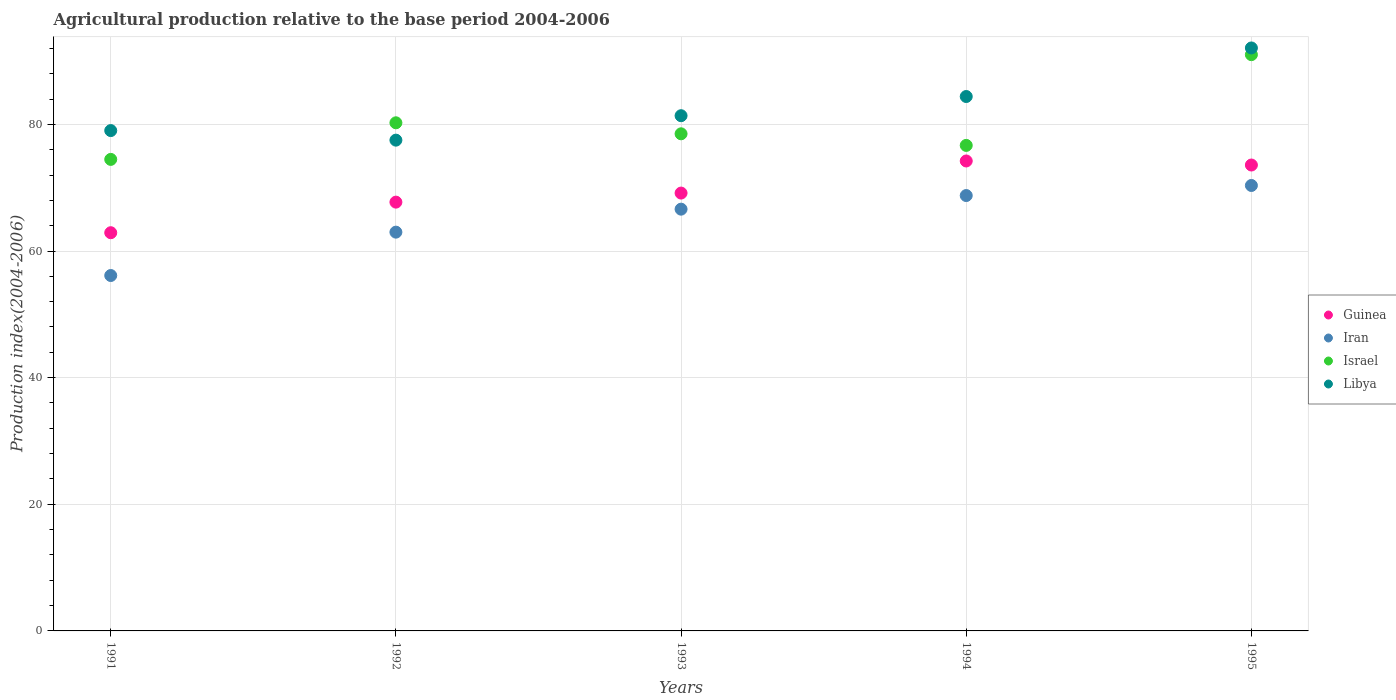Is the number of dotlines equal to the number of legend labels?
Offer a very short reply. Yes. What is the agricultural production index in Israel in 1993?
Offer a very short reply. 78.51. Across all years, what is the maximum agricultural production index in Israel?
Provide a succinct answer. 91.01. Across all years, what is the minimum agricultural production index in Libya?
Give a very brief answer. 77.51. What is the total agricultural production index in Guinea in the graph?
Ensure brevity in your answer.  347.56. What is the difference between the agricultural production index in Israel in 1992 and that in 1994?
Your answer should be compact. 3.57. What is the difference between the agricultural production index in Guinea in 1994 and the agricultural production index in Iran in 1995?
Provide a short and direct response. 3.87. What is the average agricultural production index in Israel per year?
Offer a terse response. 80.18. In the year 1991, what is the difference between the agricultural production index in Guinea and agricultural production index in Israel?
Offer a very short reply. -11.58. What is the ratio of the agricultural production index in Iran in 1992 to that in 1995?
Offer a very short reply. 0.9. Is the difference between the agricultural production index in Guinea in 1991 and 1992 greater than the difference between the agricultural production index in Israel in 1991 and 1992?
Make the answer very short. Yes. What is the difference between the highest and the second highest agricultural production index in Israel?
Offer a terse response. 10.76. What is the difference between the highest and the lowest agricultural production index in Guinea?
Offer a terse response. 11.33. Is the agricultural production index in Iran strictly less than the agricultural production index in Libya over the years?
Make the answer very short. Yes. What is the difference between two consecutive major ticks on the Y-axis?
Offer a very short reply. 20. How many legend labels are there?
Offer a very short reply. 4. How are the legend labels stacked?
Provide a short and direct response. Vertical. What is the title of the graph?
Your response must be concise. Agricultural production relative to the base period 2004-2006. Does "Small states" appear as one of the legend labels in the graph?
Provide a succinct answer. No. What is the label or title of the Y-axis?
Offer a terse response. Production index(2004-2006). What is the Production index(2004-2006) in Guinea in 1991?
Provide a short and direct response. 62.89. What is the Production index(2004-2006) of Iran in 1991?
Give a very brief answer. 56.13. What is the Production index(2004-2006) of Israel in 1991?
Ensure brevity in your answer.  74.47. What is the Production index(2004-2006) in Libya in 1991?
Provide a short and direct response. 79.02. What is the Production index(2004-2006) in Guinea in 1992?
Provide a succinct answer. 67.72. What is the Production index(2004-2006) in Iran in 1992?
Offer a very short reply. 62.98. What is the Production index(2004-2006) of Israel in 1992?
Your response must be concise. 80.25. What is the Production index(2004-2006) of Libya in 1992?
Give a very brief answer. 77.51. What is the Production index(2004-2006) in Guinea in 1993?
Make the answer very short. 69.15. What is the Production index(2004-2006) in Iran in 1993?
Ensure brevity in your answer.  66.61. What is the Production index(2004-2006) in Israel in 1993?
Your answer should be very brief. 78.51. What is the Production index(2004-2006) of Libya in 1993?
Ensure brevity in your answer.  81.37. What is the Production index(2004-2006) of Guinea in 1994?
Your answer should be very brief. 74.22. What is the Production index(2004-2006) of Iran in 1994?
Offer a very short reply. 68.76. What is the Production index(2004-2006) of Israel in 1994?
Offer a very short reply. 76.68. What is the Production index(2004-2006) of Libya in 1994?
Provide a short and direct response. 84.4. What is the Production index(2004-2006) in Guinea in 1995?
Offer a terse response. 73.58. What is the Production index(2004-2006) in Iran in 1995?
Make the answer very short. 70.35. What is the Production index(2004-2006) of Israel in 1995?
Your answer should be compact. 91.01. What is the Production index(2004-2006) in Libya in 1995?
Your answer should be compact. 92.07. Across all years, what is the maximum Production index(2004-2006) in Guinea?
Keep it short and to the point. 74.22. Across all years, what is the maximum Production index(2004-2006) in Iran?
Your answer should be compact. 70.35. Across all years, what is the maximum Production index(2004-2006) of Israel?
Provide a succinct answer. 91.01. Across all years, what is the maximum Production index(2004-2006) of Libya?
Your answer should be compact. 92.07. Across all years, what is the minimum Production index(2004-2006) of Guinea?
Offer a very short reply. 62.89. Across all years, what is the minimum Production index(2004-2006) of Iran?
Your answer should be compact. 56.13. Across all years, what is the minimum Production index(2004-2006) in Israel?
Offer a very short reply. 74.47. Across all years, what is the minimum Production index(2004-2006) of Libya?
Offer a terse response. 77.51. What is the total Production index(2004-2006) of Guinea in the graph?
Provide a succinct answer. 347.56. What is the total Production index(2004-2006) of Iran in the graph?
Your answer should be compact. 324.83. What is the total Production index(2004-2006) of Israel in the graph?
Ensure brevity in your answer.  400.92. What is the total Production index(2004-2006) in Libya in the graph?
Make the answer very short. 414.37. What is the difference between the Production index(2004-2006) of Guinea in 1991 and that in 1992?
Offer a terse response. -4.83. What is the difference between the Production index(2004-2006) of Iran in 1991 and that in 1992?
Make the answer very short. -6.85. What is the difference between the Production index(2004-2006) in Israel in 1991 and that in 1992?
Provide a short and direct response. -5.78. What is the difference between the Production index(2004-2006) of Libya in 1991 and that in 1992?
Keep it short and to the point. 1.51. What is the difference between the Production index(2004-2006) of Guinea in 1991 and that in 1993?
Offer a terse response. -6.26. What is the difference between the Production index(2004-2006) in Iran in 1991 and that in 1993?
Provide a short and direct response. -10.48. What is the difference between the Production index(2004-2006) in Israel in 1991 and that in 1993?
Your answer should be compact. -4.04. What is the difference between the Production index(2004-2006) in Libya in 1991 and that in 1993?
Provide a short and direct response. -2.35. What is the difference between the Production index(2004-2006) of Guinea in 1991 and that in 1994?
Offer a very short reply. -11.33. What is the difference between the Production index(2004-2006) of Iran in 1991 and that in 1994?
Keep it short and to the point. -12.63. What is the difference between the Production index(2004-2006) in Israel in 1991 and that in 1994?
Ensure brevity in your answer.  -2.21. What is the difference between the Production index(2004-2006) in Libya in 1991 and that in 1994?
Your response must be concise. -5.38. What is the difference between the Production index(2004-2006) in Guinea in 1991 and that in 1995?
Give a very brief answer. -10.69. What is the difference between the Production index(2004-2006) of Iran in 1991 and that in 1995?
Your response must be concise. -14.22. What is the difference between the Production index(2004-2006) of Israel in 1991 and that in 1995?
Offer a terse response. -16.54. What is the difference between the Production index(2004-2006) of Libya in 1991 and that in 1995?
Give a very brief answer. -13.05. What is the difference between the Production index(2004-2006) of Guinea in 1992 and that in 1993?
Ensure brevity in your answer.  -1.43. What is the difference between the Production index(2004-2006) of Iran in 1992 and that in 1993?
Offer a very short reply. -3.63. What is the difference between the Production index(2004-2006) of Israel in 1992 and that in 1993?
Offer a very short reply. 1.74. What is the difference between the Production index(2004-2006) in Libya in 1992 and that in 1993?
Keep it short and to the point. -3.86. What is the difference between the Production index(2004-2006) of Guinea in 1992 and that in 1994?
Offer a very short reply. -6.5. What is the difference between the Production index(2004-2006) of Iran in 1992 and that in 1994?
Keep it short and to the point. -5.78. What is the difference between the Production index(2004-2006) in Israel in 1992 and that in 1994?
Your answer should be very brief. 3.57. What is the difference between the Production index(2004-2006) of Libya in 1992 and that in 1994?
Provide a succinct answer. -6.89. What is the difference between the Production index(2004-2006) in Guinea in 1992 and that in 1995?
Your answer should be very brief. -5.86. What is the difference between the Production index(2004-2006) in Iran in 1992 and that in 1995?
Provide a short and direct response. -7.37. What is the difference between the Production index(2004-2006) in Israel in 1992 and that in 1995?
Provide a succinct answer. -10.76. What is the difference between the Production index(2004-2006) of Libya in 1992 and that in 1995?
Keep it short and to the point. -14.56. What is the difference between the Production index(2004-2006) in Guinea in 1993 and that in 1994?
Your answer should be very brief. -5.07. What is the difference between the Production index(2004-2006) in Iran in 1993 and that in 1994?
Provide a succinct answer. -2.15. What is the difference between the Production index(2004-2006) in Israel in 1993 and that in 1994?
Your answer should be compact. 1.83. What is the difference between the Production index(2004-2006) of Libya in 1993 and that in 1994?
Keep it short and to the point. -3.03. What is the difference between the Production index(2004-2006) of Guinea in 1993 and that in 1995?
Offer a terse response. -4.43. What is the difference between the Production index(2004-2006) of Iran in 1993 and that in 1995?
Keep it short and to the point. -3.74. What is the difference between the Production index(2004-2006) of Israel in 1993 and that in 1995?
Provide a succinct answer. -12.5. What is the difference between the Production index(2004-2006) in Libya in 1993 and that in 1995?
Your answer should be compact. -10.7. What is the difference between the Production index(2004-2006) of Guinea in 1994 and that in 1995?
Provide a succinct answer. 0.64. What is the difference between the Production index(2004-2006) in Iran in 1994 and that in 1995?
Make the answer very short. -1.59. What is the difference between the Production index(2004-2006) of Israel in 1994 and that in 1995?
Your answer should be very brief. -14.33. What is the difference between the Production index(2004-2006) of Libya in 1994 and that in 1995?
Your response must be concise. -7.67. What is the difference between the Production index(2004-2006) in Guinea in 1991 and the Production index(2004-2006) in Iran in 1992?
Keep it short and to the point. -0.09. What is the difference between the Production index(2004-2006) of Guinea in 1991 and the Production index(2004-2006) of Israel in 1992?
Give a very brief answer. -17.36. What is the difference between the Production index(2004-2006) of Guinea in 1991 and the Production index(2004-2006) of Libya in 1992?
Provide a short and direct response. -14.62. What is the difference between the Production index(2004-2006) in Iran in 1991 and the Production index(2004-2006) in Israel in 1992?
Provide a short and direct response. -24.12. What is the difference between the Production index(2004-2006) of Iran in 1991 and the Production index(2004-2006) of Libya in 1992?
Your answer should be very brief. -21.38. What is the difference between the Production index(2004-2006) in Israel in 1991 and the Production index(2004-2006) in Libya in 1992?
Offer a very short reply. -3.04. What is the difference between the Production index(2004-2006) of Guinea in 1991 and the Production index(2004-2006) of Iran in 1993?
Your answer should be compact. -3.72. What is the difference between the Production index(2004-2006) in Guinea in 1991 and the Production index(2004-2006) in Israel in 1993?
Provide a short and direct response. -15.62. What is the difference between the Production index(2004-2006) of Guinea in 1991 and the Production index(2004-2006) of Libya in 1993?
Offer a terse response. -18.48. What is the difference between the Production index(2004-2006) of Iran in 1991 and the Production index(2004-2006) of Israel in 1993?
Offer a terse response. -22.38. What is the difference between the Production index(2004-2006) in Iran in 1991 and the Production index(2004-2006) in Libya in 1993?
Give a very brief answer. -25.24. What is the difference between the Production index(2004-2006) in Guinea in 1991 and the Production index(2004-2006) in Iran in 1994?
Give a very brief answer. -5.87. What is the difference between the Production index(2004-2006) of Guinea in 1991 and the Production index(2004-2006) of Israel in 1994?
Offer a very short reply. -13.79. What is the difference between the Production index(2004-2006) in Guinea in 1991 and the Production index(2004-2006) in Libya in 1994?
Your response must be concise. -21.51. What is the difference between the Production index(2004-2006) of Iran in 1991 and the Production index(2004-2006) of Israel in 1994?
Ensure brevity in your answer.  -20.55. What is the difference between the Production index(2004-2006) in Iran in 1991 and the Production index(2004-2006) in Libya in 1994?
Make the answer very short. -28.27. What is the difference between the Production index(2004-2006) in Israel in 1991 and the Production index(2004-2006) in Libya in 1994?
Your response must be concise. -9.93. What is the difference between the Production index(2004-2006) in Guinea in 1991 and the Production index(2004-2006) in Iran in 1995?
Keep it short and to the point. -7.46. What is the difference between the Production index(2004-2006) in Guinea in 1991 and the Production index(2004-2006) in Israel in 1995?
Keep it short and to the point. -28.12. What is the difference between the Production index(2004-2006) in Guinea in 1991 and the Production index(2004-2006) in Libya in 1995?
Your answer should be very brief. -29.18. What is the difference between the Production index(2004-2006) in Iran in 1991 and the Production index(2004-2006) in Israel in 1995?
Offer a terse response. -34.88. What is the difference between the Production index(2004-2006) of Iran in 1991 and the Production index(2004-2006) of Libya in 1995?
Make the answer very short. -35.94. What is the difference between the Production index(2004-2006) in Israel in 1991 and the Production index(2004-2006) in Libya in 1995?
Your answer should be compact. -17.6. What is the difference between the Production index(2004-2006) in Guinea in 1992 and the Production index(2004-2006) in Iran in 1993?
Offer a very short reply. 1.11. What is the difference between the Production index(2004-2006) of Guinea in 1992 and the Production index(2004-2006) of Israel in 1993?
Keep it short and to the point. -10.79. What is the difference between the Production index(2004-2006) in Guinea in 1992 and the Production index(2004-2006) in Libya in 1993?
Keep it short and to the point. -13.65. What is the difference between the Production index(2004-2006) in Iran in 1992 and the Production index(2004-2006) in Israel in 1993?
Provide a succinct answer. -15.53. What is the difference between the Production index(2004-2006) of Iran in 1992 and the Production index(2004-2006) of Libya in 1993?
Give a very brief answer. -18.39. What is the difference between the Production index(2004-2006) of Israel in 1992 and the Production index(2004-2006) of Libya in 1993?
Your answer should be very brief. -1.12. What is the difference between the Production index(2004-2006) of Guinea in 1992 and the Production index(2004-2006) of Iran in 1994?
Offer a terse response. -1.04. What is the difference between the Production index(2004-2006) in Guinea in 1992 and the Production index(2004-2006) in Israel in 1994?
Your answer should be very brief. -8.96. What is the difference between the Production index(2004-2006) of Guinea in 1992 and the Production index(2004-2006) of Libya in 1994?
Offer a terse response. -16.68. What is the difference between the Production index(2004-2006) in Iran in 1992 and the Production index(2004-2006) in Israel in 1994?
Keep it short and to the point. -13.7. What is the difference between the Production index(2004-2006) in Iran in 1992 and the Production index(2004-2006) in Libya in 1994?
Keep it short and to the point. -21.42. What is the difference between the Production index(2004-2006) of Israel in 1992 and the Production index(2004-2006) of Libya in 1994?
Your answer should be compact. -4.15. What is the difference between the Production index(2004-2006) of Guinea in 1992 and the Production index(2004-2006) of Iran in 1995?
Provide a short and direct response. -2.63. What is the difference between the Production index(2004-2006) of Guinea in 1992 and the Production index(2004-2006) of Israel in 1995?
Provide a succinct answer. -23.29. What is the difference between the Production index(2004-2006) of Guinea in 1992 and the Production index(2004-2006) of Libya in 1995?
Ensure brevity in your answer.  -24.35. What is the difference between the Production index(2004-2006) of Iran in 1992 and the Production index(2004-2006) of Israel in 1995?
Provide a succinct answer. -28.03. What is the difference between the Production index(2004-2006) in Iran in 1992 and the Production index(2004-2006) in Libya in 1995?
Your response must be concise. -29.09. What is the difference between the Production index(2004-2006) in Israel in 1992 and the Production index(2004-2006) in Libya in 1995?
Provide a succinct answer. -11.82. What is the difference between the Production index(2004-2006) in Guinea in 1993 and the Production index(2004-2006) in Iran in 1994?
Provide a short and direct response. 0.39. What is the difference between the Production index(2004-2006) in Guinea in 1993 and the Production index(2004-2006) in Israel in 1994?
Offer a very short reply. -7.53. What is the difference between the Production index(2004-2006) of Guinea in 1993 and the Production index(2004-2006) of Libya in 1994?
Your answer should be very brief. -15.25. What is the difference between the Production index(2004-2006) in Iran in 1993 and the Production index(2004-2006) in Israel in 1994?
Your answer should be very brief. -10.07. What is the difference between the Production index(2004-2006) of Iran in 1993 and the Production index(2004-2006) of Libya in 1994?
Provide a succinct answer. -17.79. What is the difference between the Production index(2004-2006) in Israel in 1993 and the Production index(2004-2006) in Libya in 1994?
Your answer should be compact. -5.89. What is the difference between the Production index(2004-2006) of Guinea in 1993 and the Production index(2004-2006) of Israel in 1995?
Keep it short and to the point. -21.86. What is the difference between the Production index(2004-2006) of Guinea in 1993 and the Production index(2004-2006) of Libya in 1995?
Make the answer very short. -22.92. What is the difference between the Production index(2004-2006) in Iran in 1993 and the Production index(2004-2006) in Israel in 1995?
Your answer should be very brief. -24.4. What is the difference between the Production index(2004-2006) in Iran in 1993 and the Production index(2004-2006) in Libya in 1995?
Provide a succinct answer. -25.46. What is the difference between the Production index(2004-2006) of Israel in 1993 and the Production index(2004-2006) of Libya in 1995?
Your answer should be compact. -13.56. What is the difference between the Production index(2004-2006) in Guinea in 1994 and the Production index(2004-2006) in Iran in 1995?
Your answer should be compact. 3.87. What is the difference between the Production index(2004-2006) of Guinea in 1994 and the Production index(2004-2006) of Israel in 1995?
Ensure brevity in your answer.  -16.79. What is the difference between the Production index(2004-2006) of Guinea in 1994 and the Production index(2004-2006) of Libya in 1995?
Ensure brevity in your answer.  -17.85. What is the difference between the Production index(2004-2006) in Iran in 1994 and the Production index(2004-2006) in Israel in 1995?
Provide a succinct answer. -22.25. What is the difference between the Production index(2004-2006) in Iran in 1994 and the Production index(2004-2006) in Libya in 1995?
Make the answer very short. -23.31. What is the difference between the Production index(2004-2006) of Israel in 1994 and the Production index(2004-2006) of Libya in 1995?
Offer a very short reply. -15.39. What is the average Production index(2004-2006) of Guinea per year?
Ensure brevity in your answer.  69.51. What is the average Production index(2004-2006) of Iran per year?
Offer a very short reply. 64.97. What is the average Production index(2004-2006) in Israel per year?
Give a very brief answer. 80.18. What is the average Production index(2004-2006) in Libya per year?
Make the answer very short. 82.87. In the year 1991, what is the difference between the Production index(2004-2006) in Guinea and Production index(2004-2006) in Iran?
Your answer should be compact. 6.76. In the year 1991, what is the difference between the Production index(2004-2006) of Guinea and Production index(2004-2006) of Israel?
Your answer should be compact. -11.58. In the year 1991, what is the difference between the Production index(2004-2006) of Guinea and Production index(2004-2006) of Libya?
Keep it short and to the point. -16.13. In the year 1991, what is the difference between the Production index(2004-2006) in Iran and Production index(2004-2006) in Israel?
Keep it short and to the point. -18.34. In the year 1991, what is the difference between the Production index(2004-2006) of Iran and Production index(2004-2006) of Libya?
Provide a succinct answer. -22.89. In the year 1991, what is the difference between the Production index(2004-2006) of Israel and Production index(2004-2006) of Libya?
Your answer should be very brief. -4.55. In the year 1992, what is the difference between the Production index(2004-2006) in Guinea and Production index(2004-2006) in Iran?
Offer a terse response. 4.74. In the year 1992, what is the difference between the Production index(2004-2006) of Guinea and Production index(2004-2006) of Israel?
Your answer should be very brief. -12.53. In the year 1992, what is the difference between the Production index(2004-2006) of Guinea and Production index(2004-2006) of Libya?
Ensure brevity in your answer.  -9.79. In the year 1992, what is the difference between the Production index(2004-2006) in Iran and Production index(2004-2006) in Israel?
Give a very brief answer. -17.27. In the year 1992, what is the difference between the Production index(2004-2006) in Iran and Production index(2004-2006) in Libya?
Provide a short and direct response. -14.53. In the year 1992, what is the difference between the Production index(2004-2006) in Israel and Production index(2004-2006) in Libya?
Ensure brevity in your answer.  2.74. In the year 1993, what is the difference between the Production index(2004-2006) in Guinea and Production index(2004-2006) in Iran?
Ensure brevity in your answer.  2.54. In the year 1993, what is the difference between the Production index(2004-2006) in Guinea and Production index(2004-2006) in Israel?
Provide a succinct answer. -9.36. In the year 1993, what is the difference between the Production index(2004-2006) of Guinea and Production index(2004-2006) of Libya?
Offer a very short reply. -12.22. In the year 1993, what is the difference between the Production index(2004-2006) in Iran and Production index(2004-2006) in Libya?
Your answer should be very brief. -14.76. In the year 1993, what is the difference between the Production index(2004-2006) of Israel and Production index(2004-2006) of Libya?
Offer a terse response. -2.86. In the year 1994, what is the difference between the Production index(2004-2006) of Guinea and Production index(2004-2006) of Iran?
Ensure brevity in your answer.  5.46. In the year 1994, what is the difference between the Production index(2004-2006) in Guinea and Production index(2004-2006) in Israel?
Provide a succinct answer. -2.46. In the year 1994, what is the difference between the Production index(2004-2006) in Guinea and Production index(2004-2006) in Libya?
Provide a short and direct response. -10.18. In the year 1994, what is the difference between the Production index(2004-2006) in Iran and Production index(2004-2006) in Israel?
Give a very brief answer. -7.92. In the year 1994, what is the difference between the Production index(2004-2006) of Iran and Production index(2004-2006) of Libya?
Keep it short and to the point. -15.64. In the year 1994, what is the difference between the Production index(2004-2006) of Israel and Production index(2004-2006) of Libya?
Ensure brevity in your answer.  -7.72. In the year 1995, what is the difference between the Production index(2004-2006) of Guinea and Production index(2004-2006) of Iran?
Provide a short and direct response. 3.23. In the year 1995, what is the difference between the Production index(2004-2006) in Guinea and Production index(2004-2006) in Israel?
Offer a terse response. -17.43. In the year 1995, what is the difference between the Production index(2004-2006) in Guinea and Production index(2004-2006) in Libya?
Provide a short and direct response. -18.49. In the year 1995, what is the difference between the Production index(2004-2006) in Iran and Production index(2004-2006) in Israel?
Offer a very short reply. -20.66. In the year 1995, what is the difference between the Production index(2004-2006) of Iran and Production index(2004-2006) of Libya?
Provide a short and direct response. -21.72. In the year 1995, what is the difference between the Production index(2004-2006) in Israel and Production index(2004-2006) in Libya?
Offer a terse response. -1.06. What is the ratio of the Production index(2004-2006) in Guinea in 1991 to that in 1992?
Make the answer very short. 0.93. What is the ratio of the Production index(2004-2006) in Iran in 1991 to that in 1992?
Give a very brief answer. 0.89. What is the ratio of the Production index(2004-2006) of Israel in 1991 to that in 1992?
Ensure brevity in your answer.  0.93. What is the ratio of the Production index(2004-2006) in Libya in 1991 to that in 1992?
Ensure brevity in your answer.  1.02. What is the ratio of the Production index(2004-2006) in Guinea in 1991 to that in 1993?
Your response must be concise. 0.91. What is the ratio of the Production index(2004-2006) in Iran in 1991 to that in 1993?
Keep it short and to the point. 0.84. What is the ratio of the Production index(2004-2006) of Israel in 1991 to that in 1993?
Your answer should be compact. 0.95. What is the ratio of the Production index(2004-2006) in Libya in 1991 to that in 1993?
Your answer should be very brief. 0.97. What is the ratio of the Production index(2004-2006) in Guinea in 1991 to that in 1994?
Keep it short and to the point. 0.85. What is the ratio of the Production index(2004-2006) in Iran in 1991 to that in 1994?
Provide a succinct answer. 0.82. What is the ratio of the Production index(2004-2006) of Israel in 1991 to that in 1994?
Provide a short and direct response. 0.97. What is the ratio of the Production index(2004-2006) in Libya in 1991 to that in 1994?
Offer a terse response. 0.94. What is the ratio of the Production index(2004-2006) in Guinea in 1991 to that in 1995?
Offer a terse response. 0.85. What is the ratio of the Production index(2004-2006) of Iran in 1991 to that in 1995?
Your answer should be compact. 0.8. What is the ratio of the Production index(2004-2006) of Israel in 1991 to that in 1995?
Your answer should be compact. 0.82. What is the ratio of the Production index(2004-2006) of Libya in 1991 to that in 1995?
Provide a succinct answer. 0.86. What is the ratio of the Production index(2004-2006) in Guinea in 1992 to that in 1993?
Your answer should be very brief. 0.98. What is the ratio of the Production index(2004-2006) in Iran in 1992 to that in 1993?
Provide a succinct answer. 0.95. What is the ratio of the Production index(2004-2006) in Israel in 1992 to that in 1993?
Your answer should be compact. 1.02. What is the ratio of the Production index(2004-2006) in Libya in 1992 to that in 1993?
Offer a very short reply. 0.95. What is the ratio of the Production index(2004-2006) in Guinea in 1992 to that in 1994?
Make the answer very short. 0.91. What is the ratio of the Production index(2004-2006) in Iran in 1992 to that in 1994?
Provide a succinct answer. 0.92. What is the ratio of the Production index(2004-2006) of Israel in 1992 to that in 1994?
Your answer should be very brief. 1.05. What is the ratio of the Production index(2004-2006) of Libya in 1992 to that in 1994?
Ensure brevity in your answer.  0.92. What is the ratio of the Production index(2004-2006) of Guinea in 1992 to that in 1995?
Offer a terse response. 0.92. What is the ratio of the Production index(2004-2006) of Iran in 1992 to that in 1995?
Make the answer very short. 0.9. What is the ratio of the Production index(2004-2006) of Israel in 1992 to that in 1995?
Your response must be concise. 0.88. What is the ratio of the Production index(2004-2006) in Libya in 1992 to that in 1995?
Your answer should be compact. 0.84. What is the ratio of the Production index(2004-2006) in Guinea in 1993 to that in 1994?
Your answer should be compact. 0.93. What is the ratio of the Production index(2004-2006) of Iran in 1993 to that in 1994?
Make the answer very short. 0.97. What is the ratio of the Production index(2004-2006) of Israel in 1993 to that in 1994?
Ensure brevity in your answer.  1.02. What is the ratio of the Production index(2004-2006) in Libya in 1993 to that in 1994?
Keep it short and to the point. 0.96. What is the ratio of the Production index(2004-2006) of Guinea in 1993 to that in 1995?
Offer a terse response. 0.94. What is the ratio of the Production index(2004-2006) of Iran in 1993 to that in 1995?
Your answer should be very brief. 0.95. What is the ratio of the Production index(2004-2006) of Israel in 1993 to that in 1995?
Your response must be concise. 0.86. What is the ratio of the Production index(2004-2006) in Libya in 1993 to that in 1995?
Make the answer very short. 0.88. What is the ratio of the Production index(2004-2006) of Guinea in 1994 to that in 1995?
Make the answer very short. 1.01. What is the ratio of the Production index(2004-2006) in Iran in 1994 to that in 1995?
Give a very brief answer. 0.98. What is the ratio of the Production index(2004-2006) in Israel in 1994 to that in 1995?
Your response must be concise. 0.84. What is the difference between the highest and the second highest Production index(2004-2006) in Guinea?
Ensure brevity in your answer.  0.64. What is the difference between the highest and the second highest Production index(2004-2006) in Iran?
Your answer should be very brief. 1.59. What is the difference between the highest and the second highest Production index(2004-2006) of Israel?
Provide a short and direct response. 10.76. What is the difference between the highest and the second highest Production index(2004-2006) in Libya?
Ensure brevity in your answer.  7.67. What is the difference between the highest and the lowest Production index(2004-2006) of Guinea?
Keep it short and to the point. 11.33. What is the difference between the highest and the lowest Production index(2004-2006) in Iran?
Give a very brief answer. 14.22. What is the difference between the highest and the lowest Production index(2004-2006) in Israel?
Your response must be concise. 16.54. What is the difference between the highest and the lowest Production index(2004-2006) in Libya?
Give a very brief answer. 14.56. 